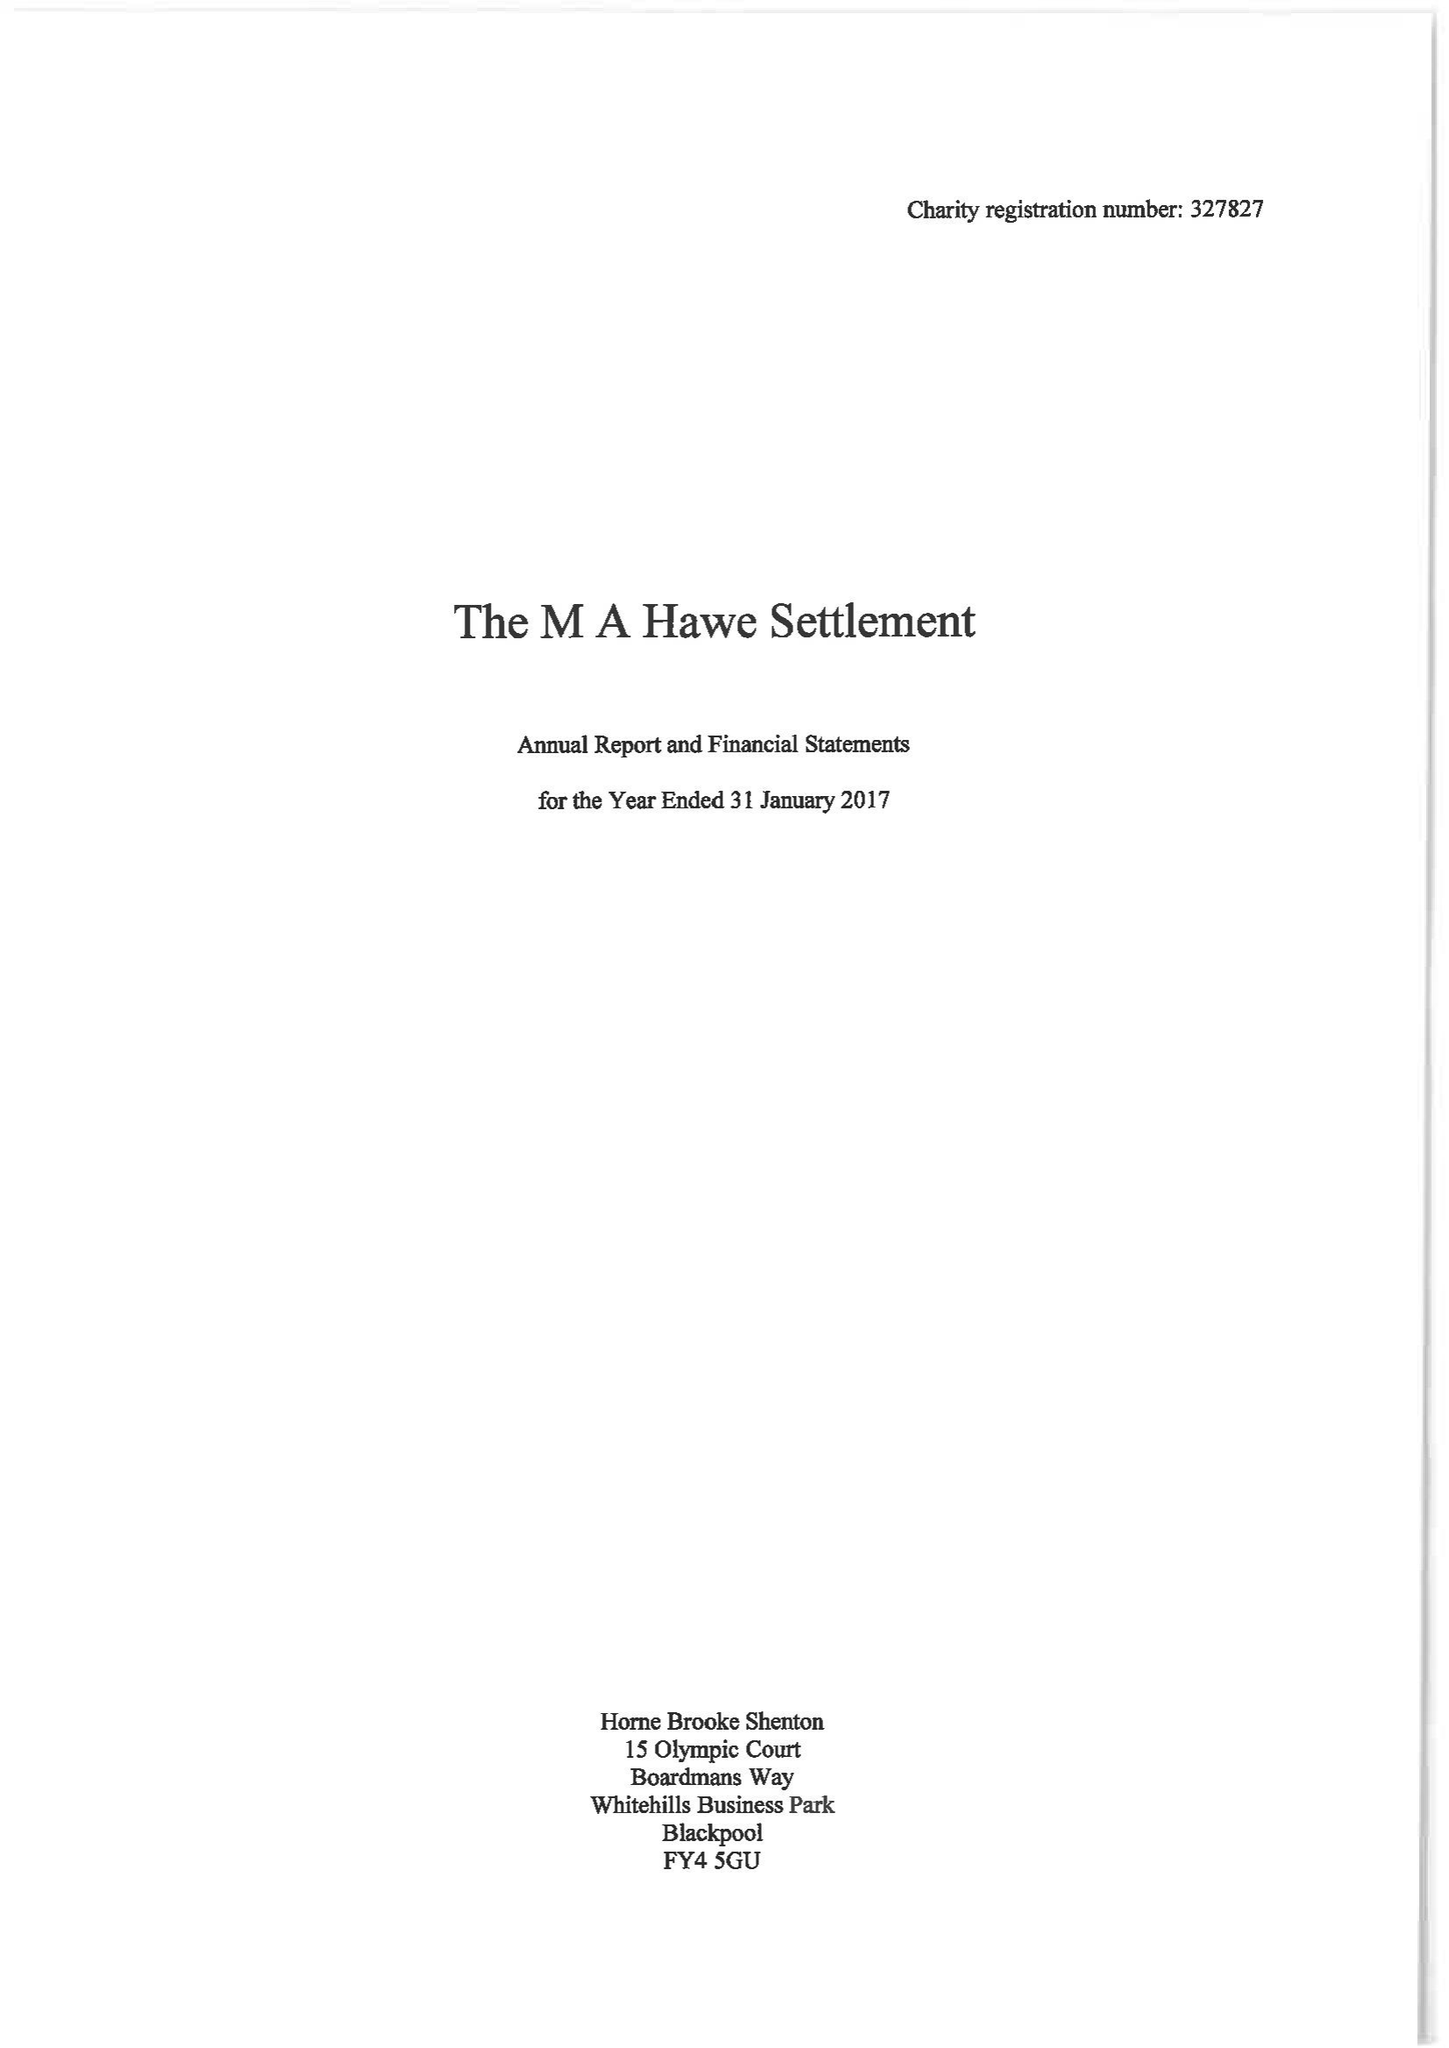What is the value for the income_annually_in_british_pounds?
Answer the question using a single word or phrase. 26210.00 